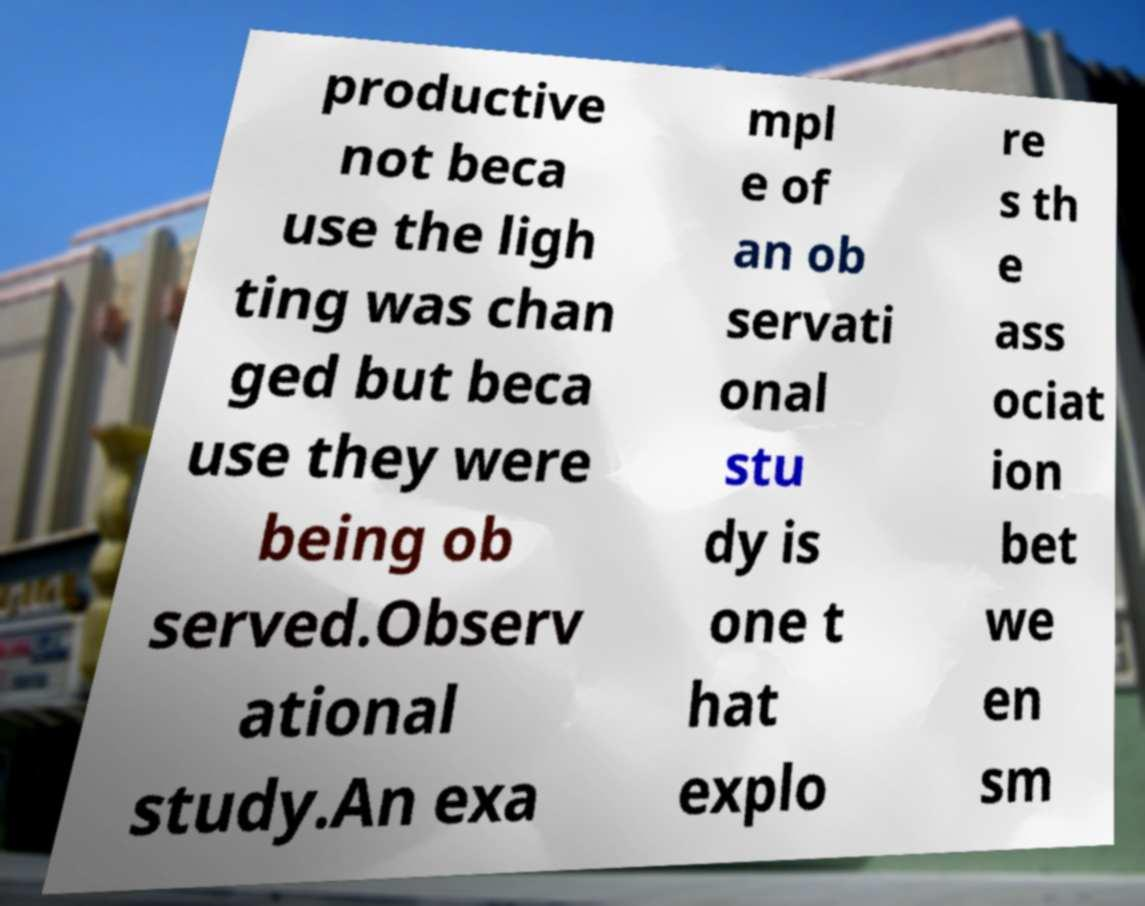Can you read and provide the text displayed in the image?This photo seems to have some interesting text. Can you extract and type it out for me? productive not beca use the ligh ting was chan ged but beca use they were being ob served.Observ ational study.An exa mpl e of an ob servati onal stu dy is one t hat explo re s th e ass ociat ion bet we en sm 